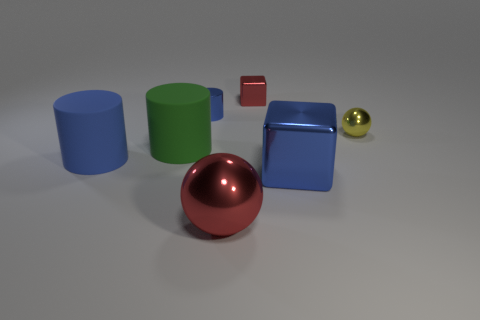Subtract all purple blocks. Subtract all red cylinders. How many blocks are left? 2 Add 1 tiny cubes. How many objects exist? 8 Subtract all balls. How many objects are left? 5 Add 4 brown matte cubes. How many brown matte cubes exist? 4 Subtract 0 brown cylinders. How many objects are left? 7 Subtract all brown things. Subtract all blue cubes. How many objects are left? 6 Add 3 green cylinders. How many green cylinders are left? 4 